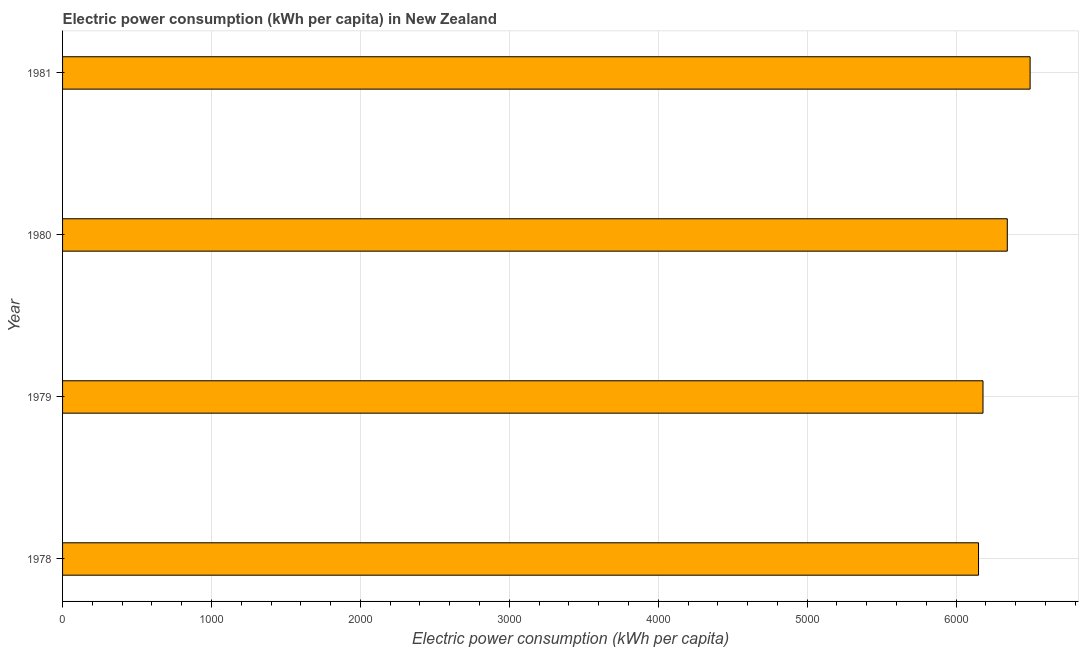Does the graph contain any zero values?
Provide a short and direct response. No. What is the title of the graph?
Give a very brief answer. Electric power consumption (kWh per capita) in New Zealand. What is the label or title of the X-axis?
Provide a short and direct response. Electric power consumption (kWh per capita). What is the label or title of the Y-axis?
Provide a short and direct response. Year. What is the electric power consumption in 1980?
Provide a succinct answer. 6343.6. Across all years, what is the maximum electric power consumption?
Provide a short and direct response. 6496.85. Across all years, what is the minimum electric power consumption?
Your answer should be very brief. 6150.52. In which year was the electric power consumption minimum?
Your response must be concise. 1978. What is the sum of the electric power consumption?
Give a very brief answer. 2.52e+04. What is the difference between the electric power consumption in 1980 and 1981?
Offer a terse response. -153.25. What is the average electric power consumption per year?
Ensure brevity in your answer.  6292.85. What is the median electric power consumption?
Offer a very short reply. 6262.02. Do a majority of the years between 1979 and 1981 (inclusive) have electric power consumption greater than 6400 kWh per capita?
Ensure brevity in your answer.  No. What is the ratio of the electric power consumption in 1979 to that in 1980?
Ensure brevity in your answer.  0.97. What is the difference between the highest and the second highest electric power consumption?
Your response must be concise. 153.25. Is the sum of the electric power consumption in 1978 and 1979 greater than the maximum electric power consumption across all years?
Offer a very short reply. Yes. What is the difference between the highest and the lowest electric power consumption?
Ensure brevity in your answer.  346.33. In how many years, is the electric power consumption greater than the average electric power consumption taken over all years?
Keep it short and to the point. 2. Are all the bars in the graph horizontal?
Ensure brevity in your answer.  Yes. What is the difference between two consecutive major ticks on the X-axis?
Your answer should be compact. 1000. Are the values on the major ticks of X-axis written in scientific E-notation?
Your answer should be compact. No. What is the Electric power consumption (kWh per capita) of 1978?
Provide a succinct answer. 6150.52. What is the Electric power consumption (kWh per capita) of 1979?
Keep it short and to the point. 6180.44. What is the Electric power consumption (kWh per capita) of 1980?
Ensure brevity in your answer.  6343.6. What is the Electric power consumption (kWh per capita) of 1981?
Your answer should be very brief. 6496.85. What is the difference between the Electric power consumption (kWh per capita) in 1978 and 1979?
Make the answer very short. -29.92. What is the difference between the Electric power consumption (kWh per capita) in 1978 and 1980?
Provide a succinct answer. -193.08. What is the difference between the Electric power consumption (kWh per capita) in 1978 and 1981?
Ensure brevity in your answer.  -346.33. What is the difference between the Electric power consumption (kWh per capita) in 1979 and 1980?
Make the answer very short. -163.16. What is the difference between the Electric power consumption (kWh per capita) in 1979 and 1981?
Give a very brief answer. -316.4. What is the difference between the Electric power consumption (kWh per capita) in 1980 and 1981?
Offer a very short reply. -153.25. What is the ratio of the Electric power consumption (kWh per capita) in 1978 to that in 1981?
Make the answer very short. 0.95. What is the ratio of the Electric power consumption (kWh per capita) in 1979 to that in 1981?
Offer a very short reply. 0.95. 